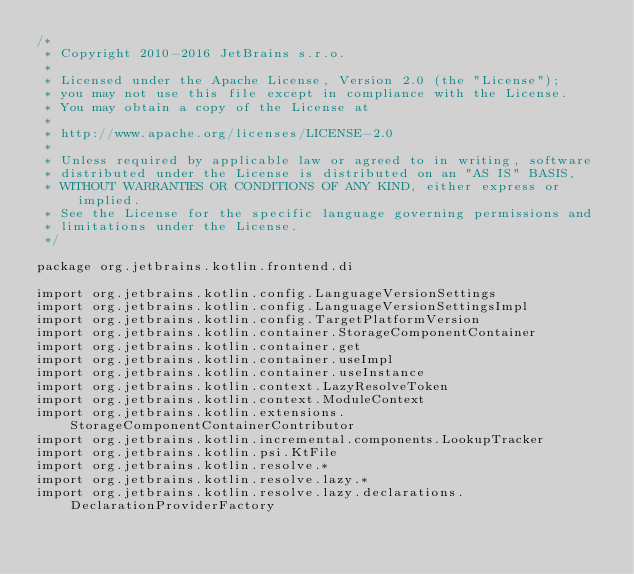Convert code to text. <code><loc_0><loc_0><loc_500><loc_500><_Kotlin_>/*
 * Copyright 2010-2016 JetBrains s.r.o.
 *
 * Licensed under the Apache License, Version 2.0 (the "License");
 * you may not use this file except in compliance with the License.
 * You may obtain a copy of the License at
 *
 * http://www.apache.org/licenses/LICENSE-2.0
 *
 * Unless required by applicable law or agreed to in writing, software
 * distributed under the License is distributed on an "AS IS" BASIS,
 * WITHOUT WARRANTIES OR CONDITIONS OF ANY KIND, either express or implied.
 * See the License for the specific language governing permissions and
 * limitations under the License.
 */

package org.jetbrains.kotlin.frontend.di

import org.jetbrains.kotlin.config.LanguageVersionSettings
import org.jetbrains.kotlin.config.LanguageVersionSettingsImpl
import org.jetbrains.kotlin.config.TargetPlatformVersion
import org.jetbrains.kotlin.container.StorageComponentContainer
import org.jetbrains.kotlin.container.get
import org.jetbrains.kotlin.container.useImpl
import org.jetbrains.kotlin.container.useInstance
import org.jetbrains.kotlin.context.LazyResolveToken
import org.jetbrains.kotlin.context.ModuleContext
import org.jetbrains.kotlin.extensions.StorageComponentContainerContributor
import org.jetbrains.kotlin.incremental.components.LookupTracker
import org.jetbrains.kotlin.psi.KtFile
import org.jetbrains.kotlin.resolve.*
import org.jetbrains.kotlin.resolve.lazy.*
import org.jetbrains.kotlin.resolve.lazy.declarations.DeclarationProviderFactory</code> 